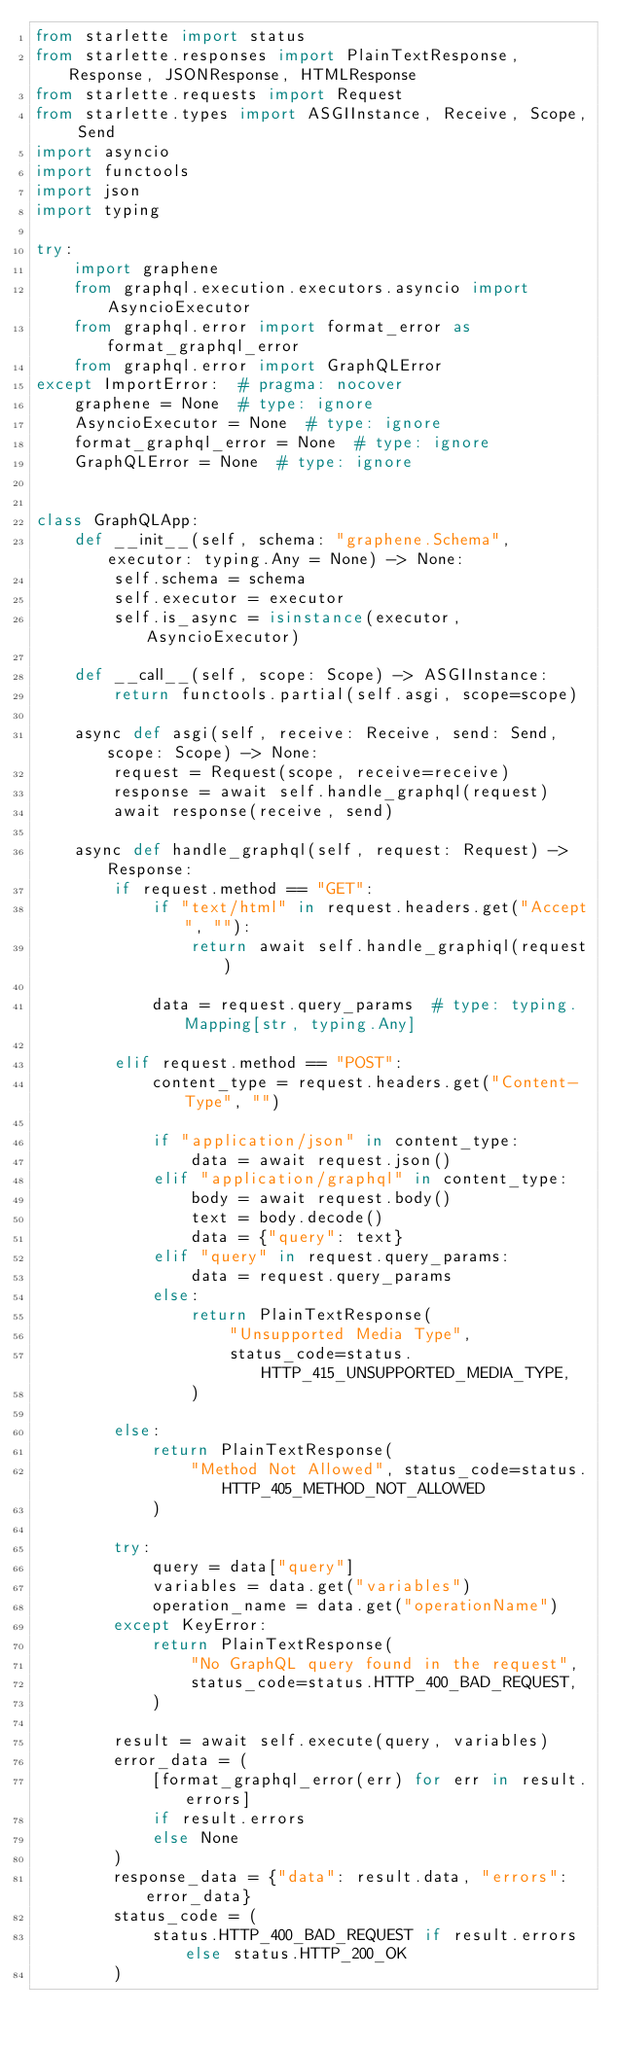Convert code to text. <code><loc_0><loc_0><loc_500><loc_500><_Python_>from starlette import status
from starlette.responses import PlainTextResponse, Response, JSONResponse, HTMLResponse
from starlette.requests import Request
from starlette.types import ASGIInstance, Receive, Scope, Send
import asyncio
import functools
import json
import typing

try:
    import graphene
    from graphql.execution.executors.asyncio import AsyncioExecutor
    from graphql.error import format_error as format_graphql_error
    from graphql.error import GraphQLError
except ImportError:  # pragma: nocover
    graphene = None  # type: ignore
    AsyncioExecutor = None  # type: ignore
    format_graphql_error = None  # type: ignore
    GraphQLError = None  # type: ignore


class GraphQLApp:
    def __init__(self, schema: "graphene.Schema", executor: typing.Any = None) -> None:
        self.schema = schema
        self.executor = executor
        self.is_async = isinstance(executor, AsyncioExecutor)

    def __call__(self, scope: Scope) -> ASGIInstance:
        return functools.partial(self.asgi, scope=scope)

    async def asgi(self, receive: Receive, send: Send, scope: Scope) -> None:
        request = Request(scope, receive=receive)
        response = await self.handle_graphql(request)
        await response(receive, send)

    async def handle_graphql(self, request: Request) -> Response:
        if request.method == "GET":
            if "text/html" in request.headers.get("Accept", ""):
                return await self.handle_graphiql(request)

            data = request.query_params  # type: typing.Mapping[str, typing.Any]

        elif request.method == "POST":
            content_type = request.headers.get("Content-Type", "")

            if "application/json" in content_type:
                data = await request.json()
            elif "application/graphql" in content_type:
                body = await request.body()
                text = body.decode()
                data = {"query": text}
            elif "query" in request.query_params:
                data = request.query_params
            else:
                return PlainTextResponse(
                    "Unsupported Media Type",
                    status_code=status.HTTP_415_UNSUPPORTED_MEDIA_TYPE,
                )

        else:
            return PlainTextResponse(
                "Method Not Allowed", status_code=status.HTTP_405_METHOD_NOT_ALLOWED
            )

        try:
            query = data["query"]
            variables = data.get("variables")
            operation_name = data.get("operationName")
        except KeyError:
            return PlainTextResponse(
                "No GraphQL query found in the request",
                status_code=status.HTTP_400_BAD_REQUEST,
            )

        result = await self.execute(query, variables)
        error_data = (
            [format_graphql_error(err) for err in result.errors]
            if result.errors
            else None
        )
        response_data = {"data": result.data, "errors": error_data}
        status_code = (
            status.HTTP_400_BAD_REQUEST if result.errors else status.HTTP_200_OK
        )</code> 